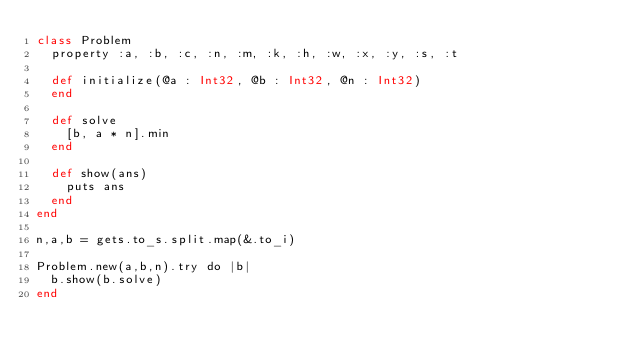Convert code to text. <code><loc_0><loc_0><loc_500><loc_500><_Crystal_>class Problem
  property :a, :b, :c, :n, :m, :k, :h, :w, :x, :y, :s, :t

  def initialize(@a : Int32, @b : Int32, @n : Int32)
  end

  def solve
    [b, a * n].min
  end

  def show(ans)
    puts ans
  end
end

n,a,b = gets.to_s.split.map(&.to_i)

Problem.new(a,b,n).try do |b|
  b.show(b.solve)
end
</code> 